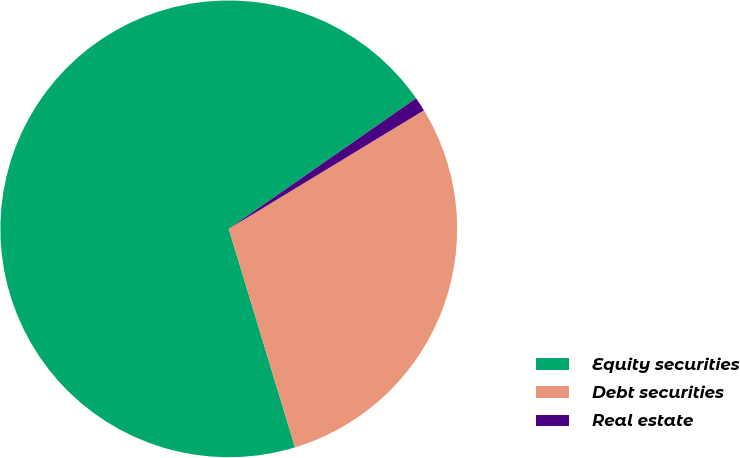<chart> <loc_0><loc_0><loc_500><loc_500><pie_chart><fcel>Equity securities<fcel>Debt securities<fcel>Real estate<nl><fcel>70.0%<fcel>29.0%<fcel>1.0%<nl></chart> 